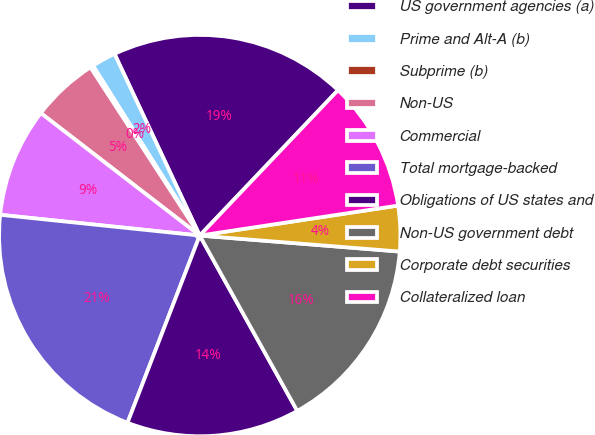Convert chart to OTSL. <chart><loc_0><loc_0><loc_500><loc_500><pie_chart><fcel>US government agencies (a)<fcel>Prime and Alt-A (b)<fcel>Subprime (b)<fcel>Non-US<fcel>Commercial<fcel>Total mortgage-backed<fcel>Obligations of US states and<fcel>Non-US government debt<fcel>Corporate debt securities<fcel>Collateralized loan<nl><fcel>19.08%<fcel>1.95%<fcel>0.24%<fcel>5.38%<fcel>8.8%<fcel>20.79%<fcel>13.94%<fcel>15.65%<fcel>3.66%<fcel>10.51%<nl></chart> 